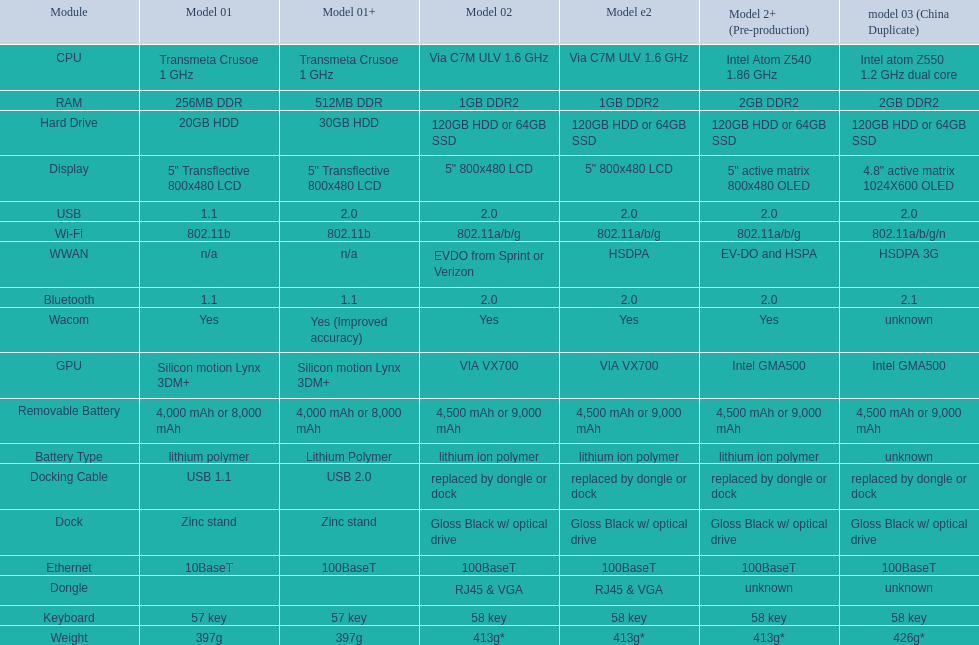How many models have 1.6ghz? 2. 